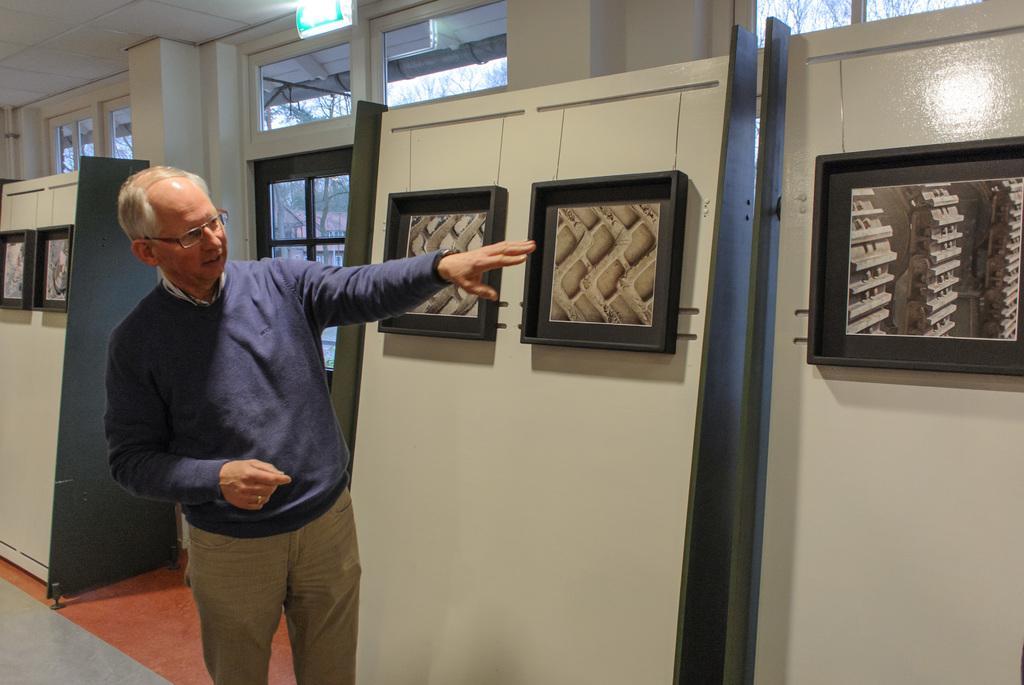Please provide a concise description of this image. In this picture I can see a man standing and I can see few photo frames and I can see a glass door and man wore spectacles and I can see trees from the glass door. 